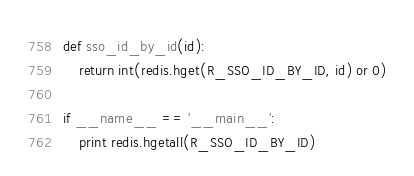Convert code to text. <code><loc_0><loc_0><loc_500><loc_500><_Python_>def sso_id_by_id(id):
    return int(redis.hget(R_SSO_ID_BY_ID, id) or 0)

if __name__ == '__main__':
    print redis.hgetall(R_SSO_ID_BY_ID)
</code> 